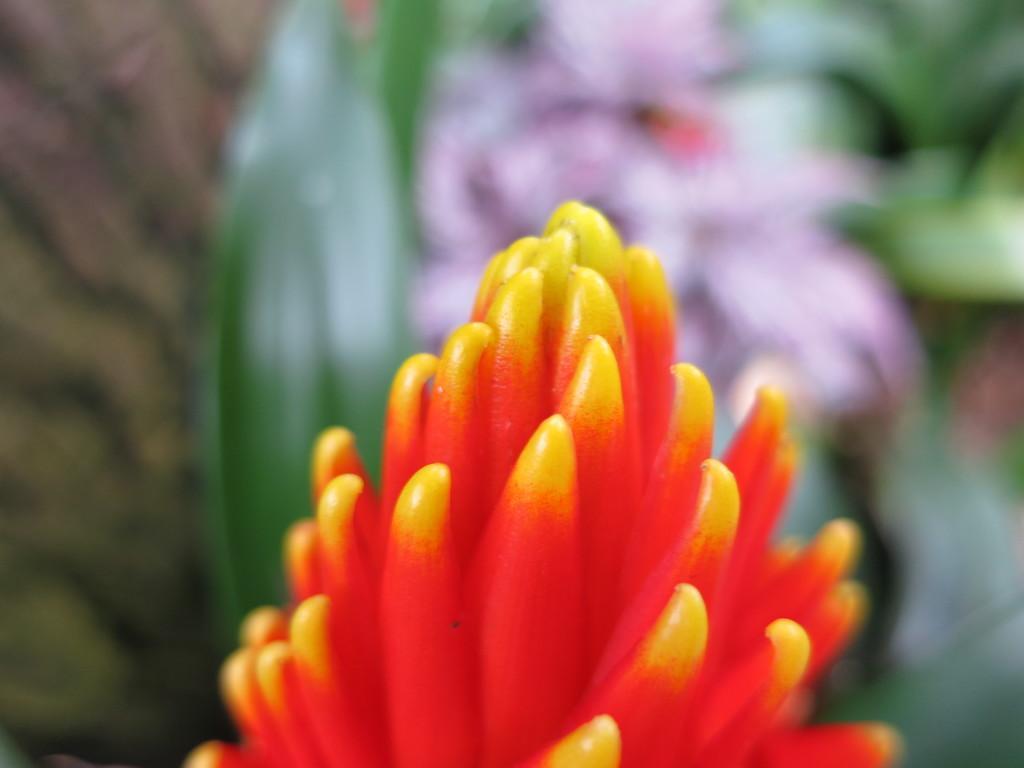Can you describe this image briefly? At the bottom we can see a flower. In the background the image is blur but we can see leaves and flowers. 